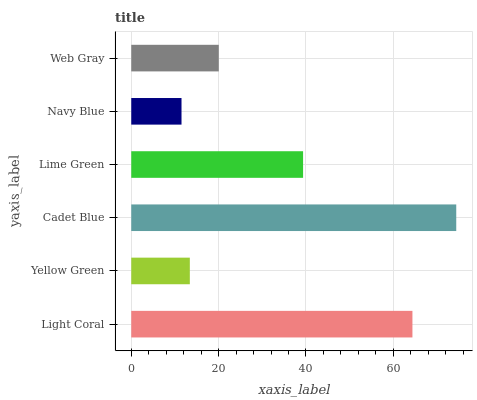Is Navy Blue the minimum?
Answer yes or no. Yes. Is Cadet Blue the maximum?
Answer yes or no. Yes. Is Yellow Green the minimum?
Answer yes or no. No. Is Yellow Green the maximum?
Answer yes or no. No. Is Light Coral greater than Yellow Green?
Answer yes or no. Yes. Is Yellow Green less than Light Coral?
Answer yes or no. Yes. Is Yellow Green greater than Light Coral?
Answer yes or no. No. Is Light Coral less than Yellow Green?
Answer yes or no. No. Is Lime Green the high median?
Answer yes or no. Yes. Is Web Gray the low median?
Answer yes or no. Yes. Is Cadet Blue the high median?
Answer yes or no. No. Is Lime Green the low median?
Answer yes or no. No. 